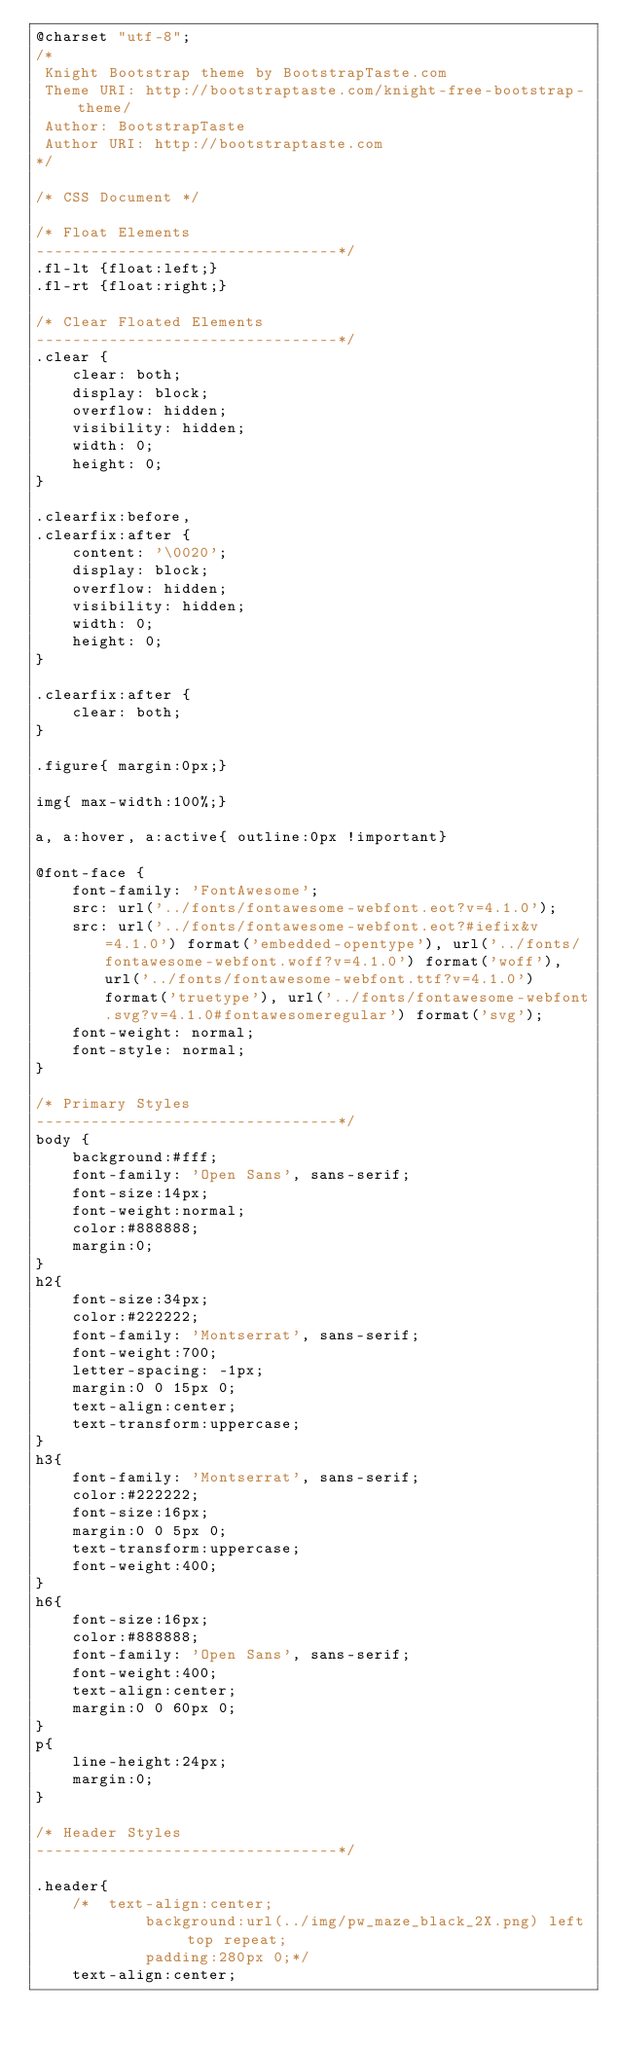<code> <loc_0><loc_0><loc_500><loc_500><_CSS_>@charset "utf-8";
/*
 Knight Bootstrap theme by BootstrapTaste.com
 Theme URI: http://bootstraptaste.com/knight-free-bootstrap-theme/
 Author: BootstrapTaste
 Author URI: http://bootstraptaste.com
*/

/* CSS Document */

/* Float Elements 
---------------------------------*/
.fl-lt {float:left;}
.fl-rt {float:right;}

/* Clear Floated Elements
---------------------------------*/
.clear {
    clear: both;
    display: block;
    overflow: hidden;
    visibility: hidden;
    width: 0;
    height: 0;
}

.clearfix:before,
.clearfix:after {
    content: '\0020';
    display: block;
    overflow: hidden;
    visibility: hidden;
    width: 0;
    height: 0;
}

.clearfix:after {
    clear: both;
}

.figure{ margin:0px;}

img{ max-width:100%;}

a, a:hover, a:active{ outline:0px !important}

@font-face {
    font-family: 'FontAwesome';
    src: url('../fonts/fontawesome-webfont.eot?v=4.1.0');
    src: url('../fonts/fontawesome-webfont.eot?#iefix&v=4.1.0') format('embedded-opentype'), url('../fonts/fontawesome-webfont.woff?v=4.1.0') format('woff'), url('../fonts/fontawesome-webfont.ttf?v=4.1.0') format('truetype'), url('../fonts/fontawesome-webfont.svg?v=4.1.0#fontawesomeregular') format('svg');
    font-weight: normal;
    font-style: normal;
}

/* Primary Styles
---------------------------------*/
body {
    background:#fff;
    font-family: 'Open Sans', sans-serif;
    font-size:14px;
    font-weight:normal;
    color:#888888;
    margin:0;
}
h2{
    font-size:34px;
    color:#222222;
    font-family: 'Montserrat', sans-serif;
    font-weight:700;
    letter-spacing: -1px;
    margin:0 0 15px 0;
    text-align:center;
    text-transform:uppercase;
}
h3{
    font-family: 'Montserrat', sans-serif;
    color:#222222;
    font-size:16px;
    margin:0 0 5px 0;
    text-transform:uppercase;
    font-weight:400;
}
h6{
    font-size:16px;
    color:#888888;
    font-family: 'Open Sans', sans-serif;
    font-weight:400;
    text-align:center;
    margin:0 0 60px 0;
}
p{
    line-height:24px;
    margin:0;
}

/* Header Styles
---------------------------------*/

.header{
    /*	text-align:center;
            background:url(../img/pw_maze_black_2X.png) left top repeat;
            padding:280px 0;*/
    text-align:center;</code> 